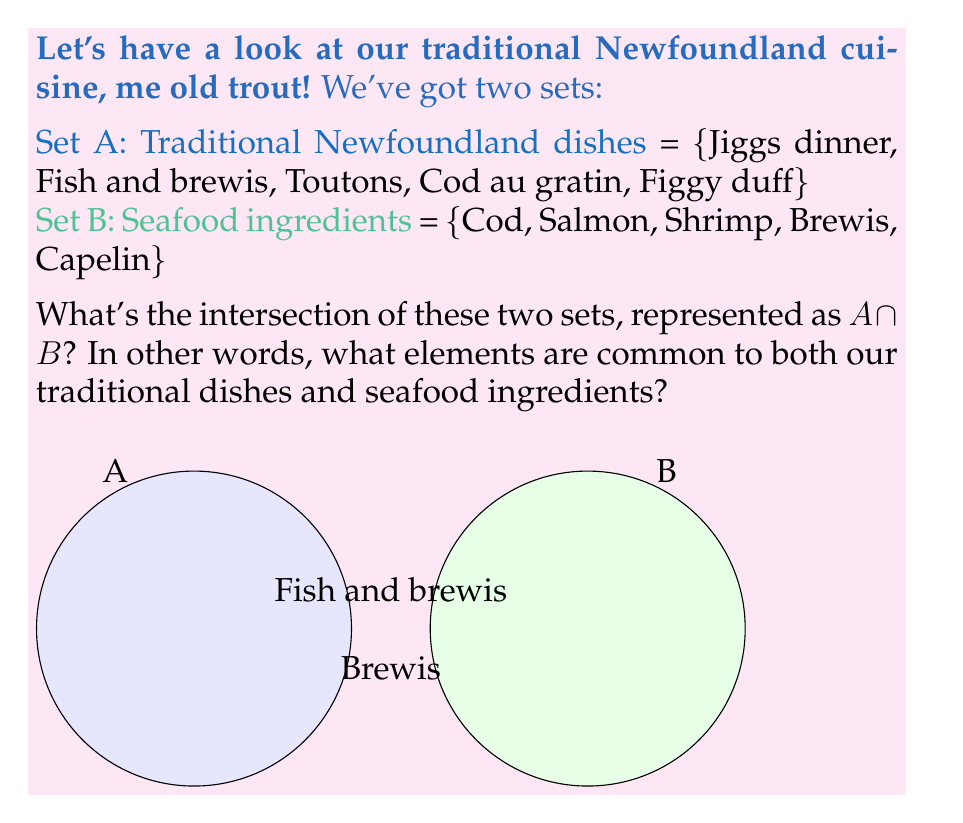Help me with this question. Let's break this down step by step, my son:

1) First, we need to identify the elements in each set:
   Set A = {Jiggs dinner, Fish and brewis, Toutons, Cod au gratin, Figgy duff}
   Set B = {Cod, Salmon, Shrimp, Brewis, Capelin}

2) The intersection of these sets, $A \cap B$, includes elements that are present in both sets.

3) Looking at Set A, we see "Fish and brewis" which contains "Brewis", an element also found in Set B.

4) "Cod au gratin" in Set A contains "Cod", which is also in Set B. However, we're looking for exact matches, not partial ones, so this doesn't count.

5) No other elements appear in both sets.

Therefore, the intersection of these sets contains two elements: "Fish and brewis" (as a complete dish name) and "Brewis" (as an ingredient).

Mathematically, we can express this as:

$$A \cap B = \text{\{Fish and brewis, Brewis\}}$$

This intersection shows that "Brewis", a type of hard bread, is both a key ingredient in seafood dishes and a part of a traditional Newfoundland meal, demonstrating the importance of seafood in our local cuisine.
Answer: $\text{\{Fish and brewis, Brewis\}}$ 